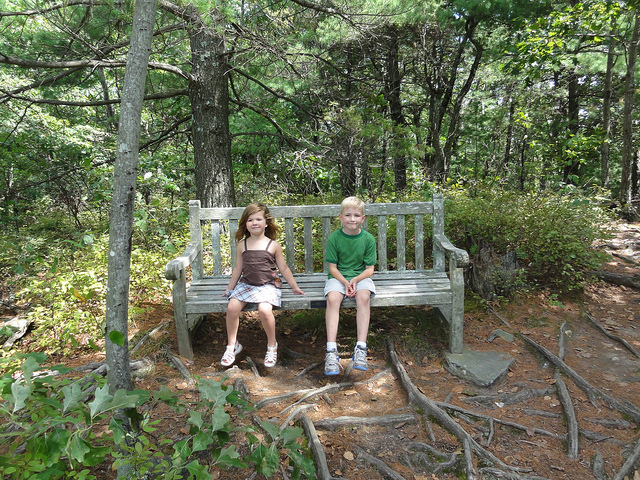What could likely happen to you on this bench?
A. get seasick
B. get sunburn
C. get lost
D. sandy feet B. Given that this bench is placed outdoors in a sunny, wooded area, it is likely that you could get sunburned if you sit here for an extended period without protection. 